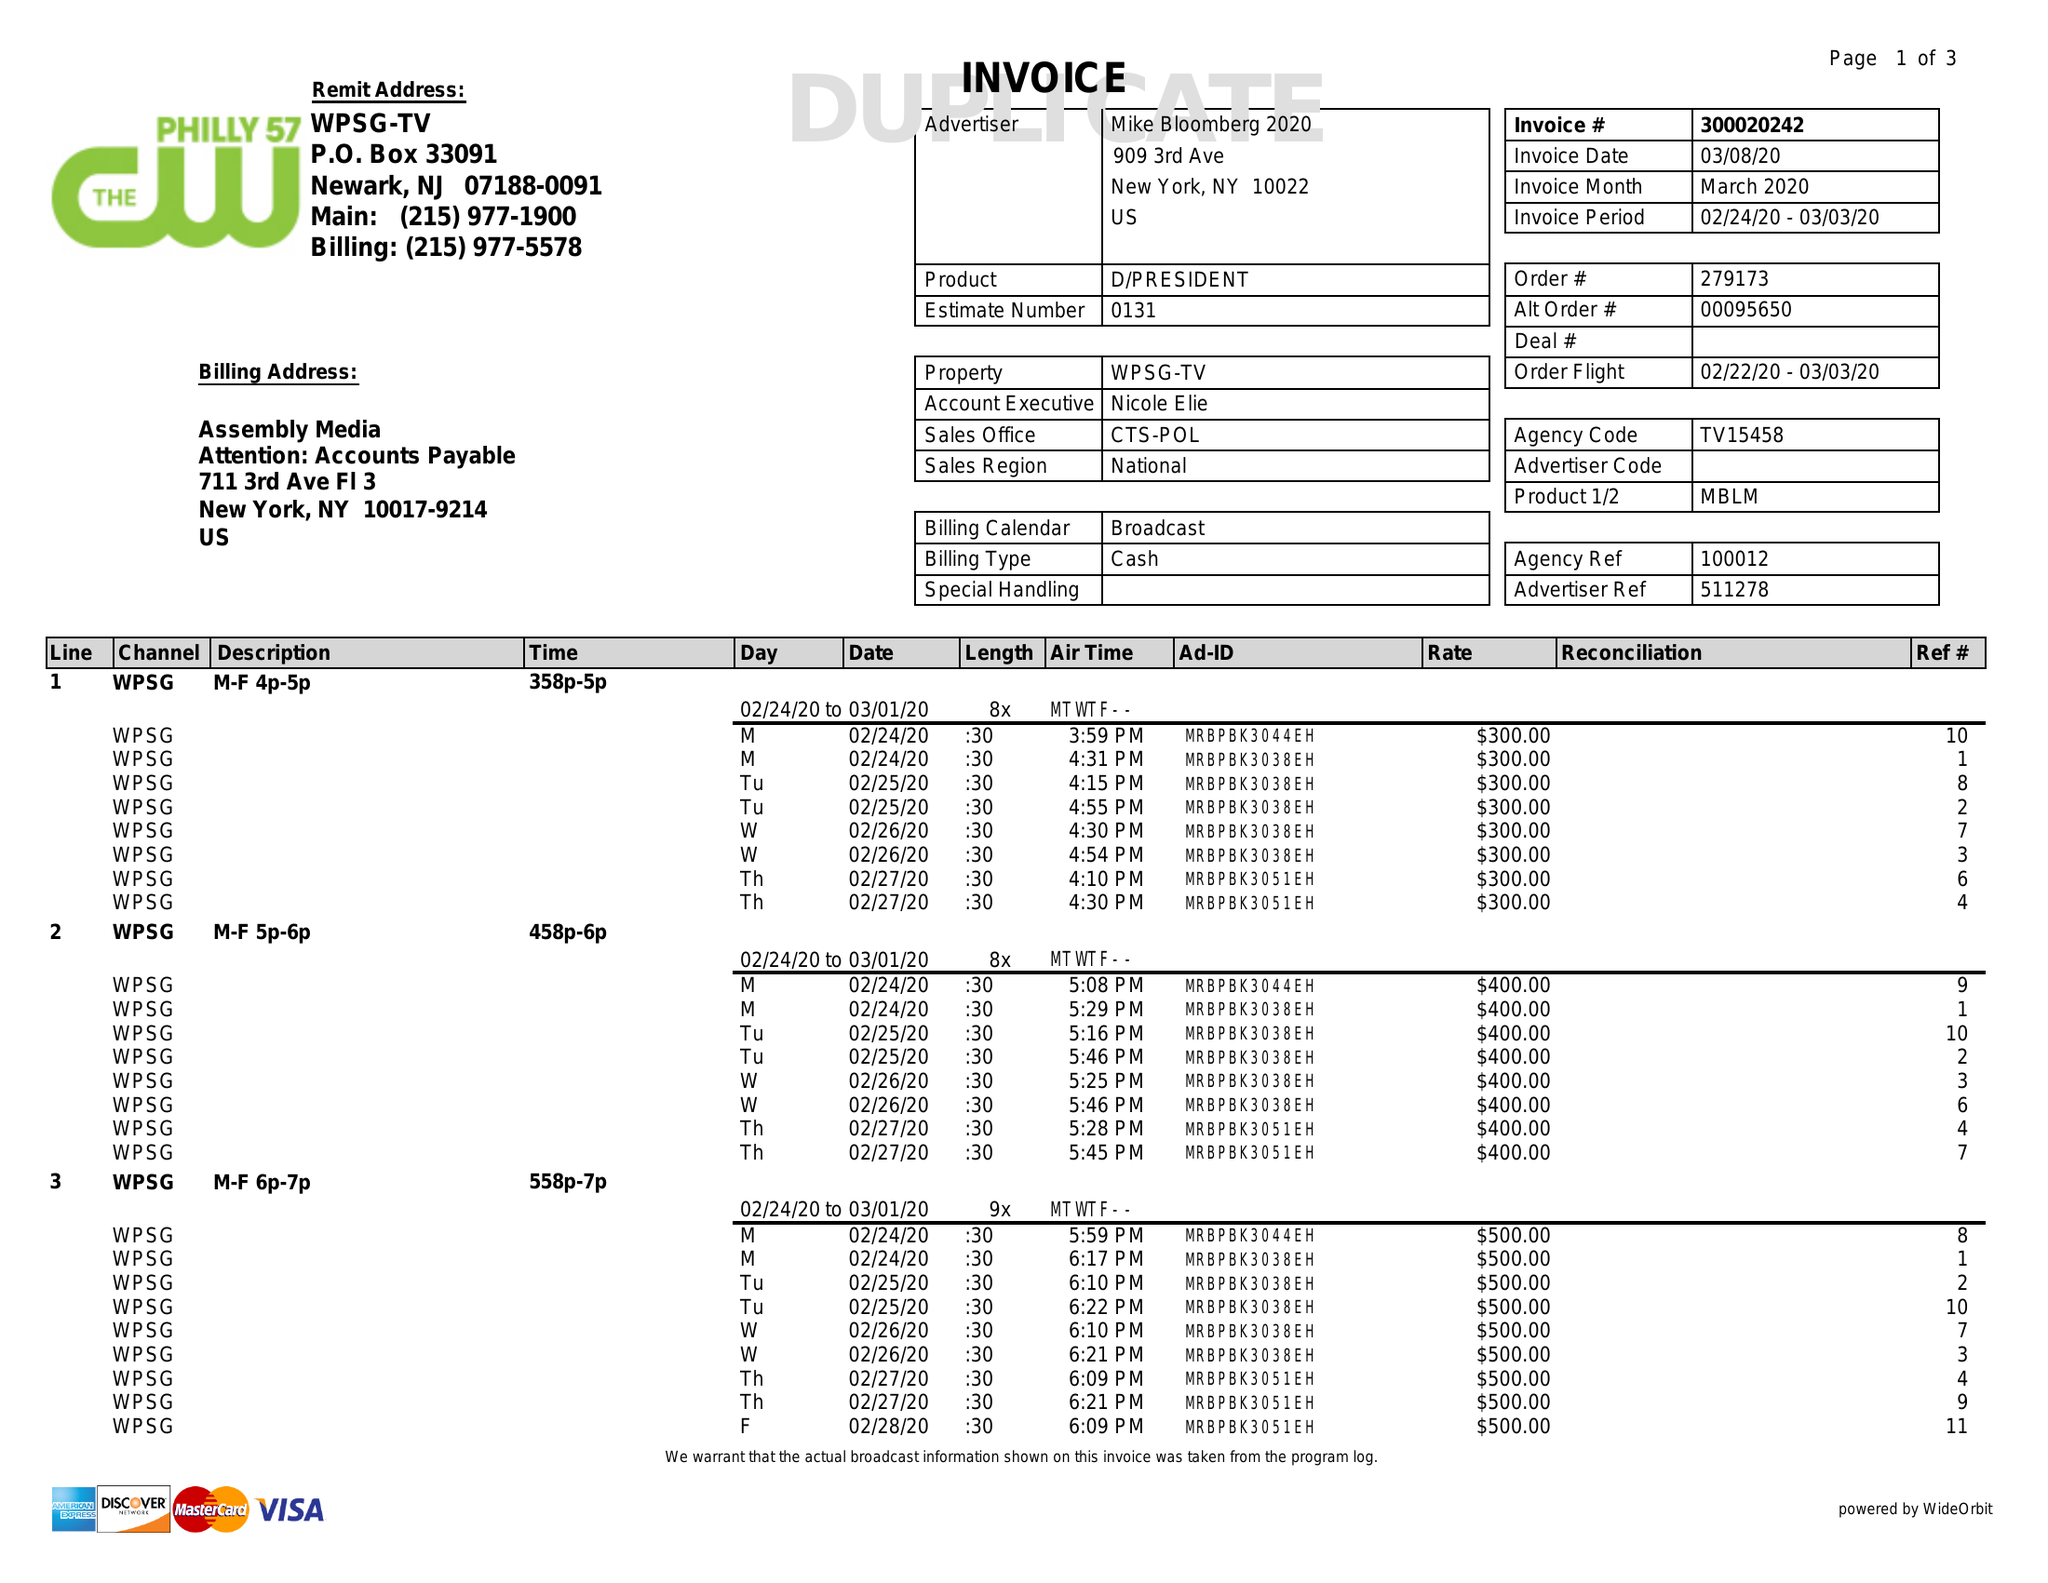What is the value for the flight_to?
Answer the question using a single word or phrase. 03/03/20 